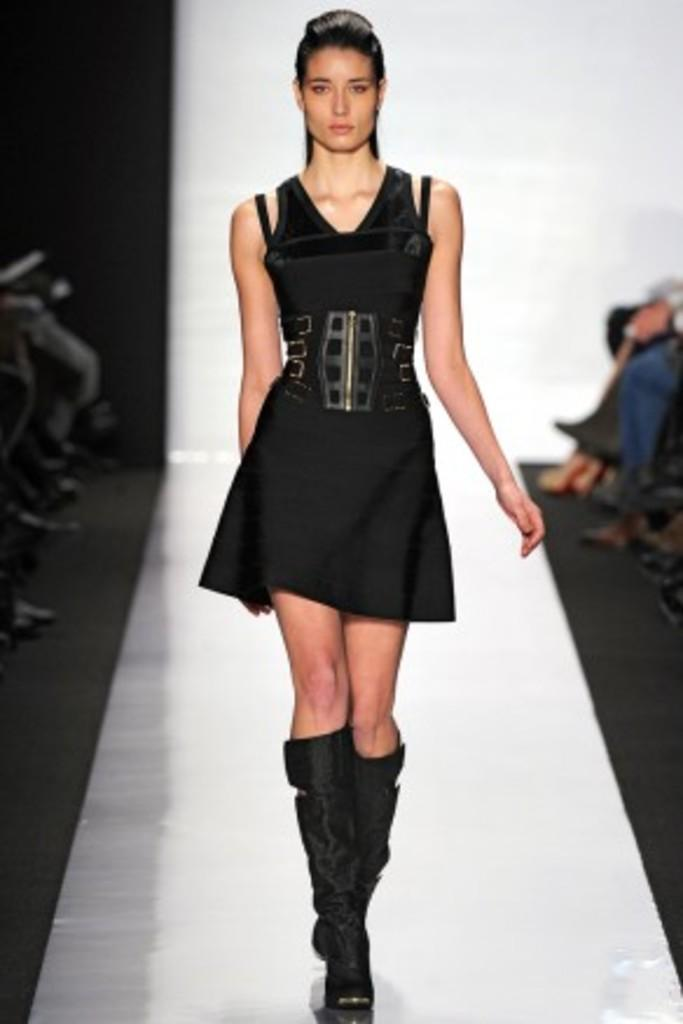What is the main subject of the image? There is a beautiful woman in the image. What is the woman doing in the image? The woman is doing a catwalk on a ramp. What color is the dress the woman is wearing? The woman is wearing a black color dress. What type of bone can be seen in the woman's hand in the image? There is no bone visible in the woman's hand in the image. What is the weather like in the image? The provided facts do not mention the weather, so we cannot determine the weather from the image. 